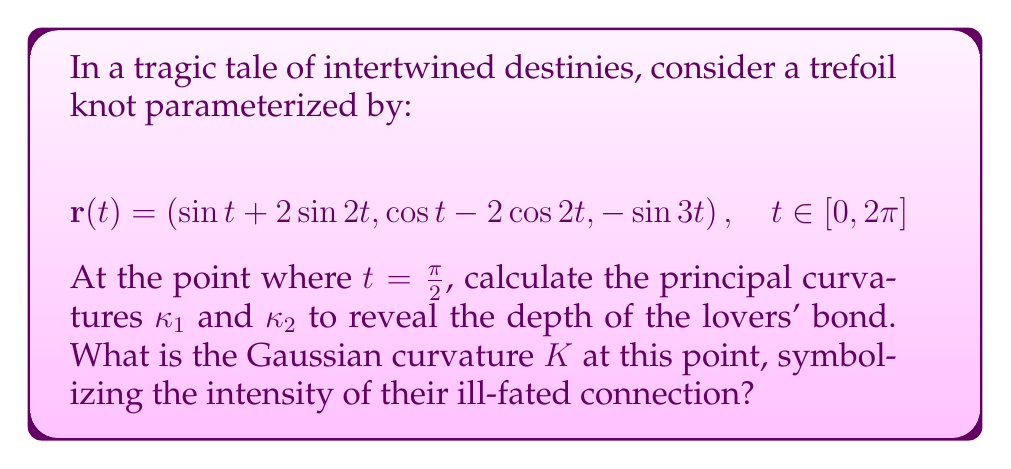Provide a solution to this math problem. Let's approach this step-by-step, unraveling the complexity of our lovers' fate:

1) First, we need to calculate $\mathbf{r}'(t)$ and $\mathbf{r}''(t)$:

   $$\mathbf{r}'(t) = (\cos t + 4 \cos 2t, -\sin t + 4 \sin 2t, -3 \cos 3t)$$
   $$\mathbf{r}''(t) = (-\sin t - 8 \sin 2t, -\cos t + 8 \cos 2t, 9 \sin 3t)$$

2) At $t = \frac{\pi}{2}$:

   $$\mathbf{r}'(\frac{\pi}{2}) = (1, 4, 3)$$
   $$\mathbf{r}''(\frac{\pi}{2}) = (-1, -1, 0)$$

3) Calculate the unit tangent vector $\mathbf{T}$:

   $$\mathbf{T} = \frac{\mathbf{r}'}{\|\mathbf{r}'\|} = \frac{(1, 4, 3)}{\sqrt{1^2 + 4^2 + 3^2}} = \frac{(1, 4, 3)}{\sqrt{26}}$$

4) Calculate the curvature $\kappa$:

   $$\kappa = \frac{\|\mathbf{r}' \times \mathbf{r}''\|}{\|\mathbf{r}'\|^3}$$

   $$\|\mathbf{r}' \times \mathbf{r}''\| = \|(4, -3, -3)\| = \sqrt{34}$$
   $$\|\mathbf{r}'\| = \sqrt{26}$$

   $$\kappa = \frac{\sqrt{34}}{(\sqrt{26})^3} = \frac{\sqrt{34}}{26\sqrt{26}}$$

5) The normal vector $\mathbf{N}$ is:

   $$\mathbf{N} = \frac{\mathbf{r}' \times \mathbf{r}''}{\|\mathbf{r}' \times \mathbf{r}''\|} = \frac{(4, -3, -3)}{\sqrt{34}}$$

6) Calculate the torsion $\tau$:

   $$\tau = \frac{(\mathbf{r}' \times \mathbf{r}'') \cdot \mathbf{r}'''}{\|\mathbf{r}' \times \mathbf{r}''\|^2}$$

   We need $\mathbf{r}'''(\frac{\pi}{2}) = (-1, 4, -27)$

   $$\tau = \frac{(4, -3, -3) \cdot (-1, 4, -27)}{34} = \frac{-4 - 12 + 81}{34} = \frac{65}{34}$$

7) The principal curvatures are given by:

   $$\kappa_1 = \kappa + \sqrt{\kappa^2 + \tau^2}$$
   $$\kappa_2 = \kappa - \sqrt{\kappa^2 + \tau^2}$$

   Substituting our values:

   $$\kappa_1 = \frac{\sqrt{34}}{26\sqrt{26}} + \sqrt{\frac{34}{676 \cdot 26} + \frac{65^2}{34^2}}$$
   $$\kappa_2 = \frac{\sqrt{34}}{26\sqrt{26}} - \sqrt{\frac{34}{676 \cdot 26} + \frac{65^2}{34^2}}$$

8) The Gaussian curvature $K$ is the product of the principal curvatures:

   $$K = \kappa_1 \kappa_2 = \kappa^2 = \frac{34}{676 \cdot 26} = \frac{1}{520}$$
Answer: $K = \frac{1}{520}$ 